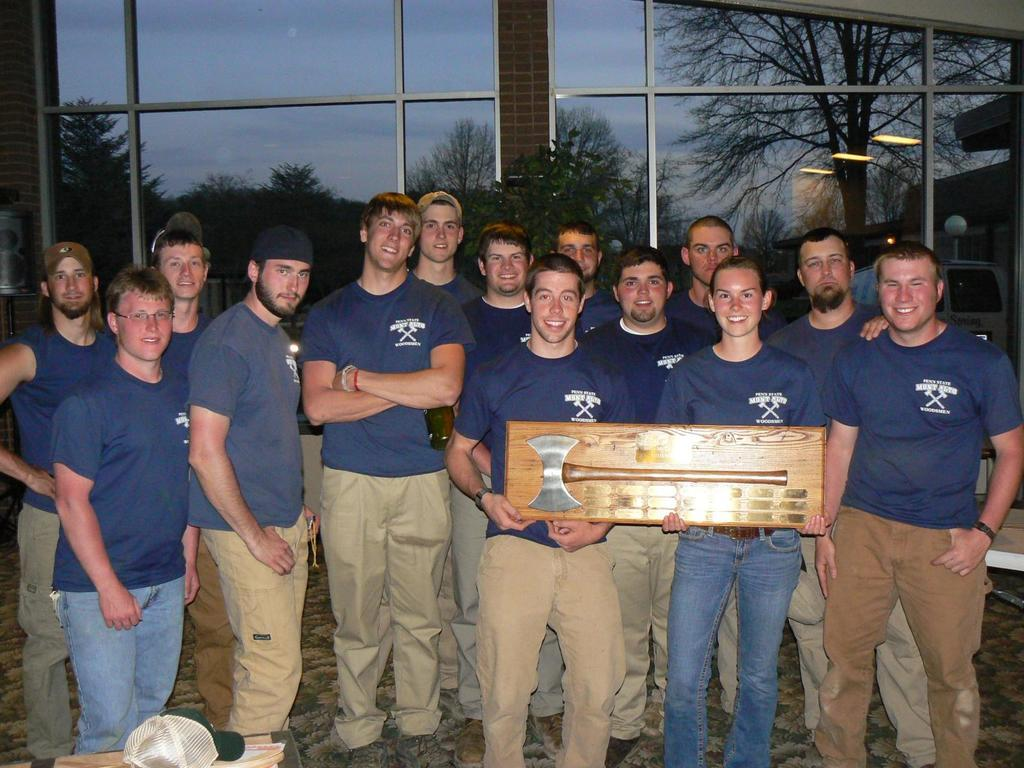What are the people in the image doing? There are men standing in the image. What object can be seen in the image that is typically used for chopping? There is an axe in the image. What type of natural vegetation is present in the image? There are trees in the image. What type of headwear is visible in the image? There is a cap in the image. What type of container is present in the image? There is a glass in the image. What type of spoon is being used to express hate in the image? There is no spoon present in the image, and no expression of hate can be observed. 